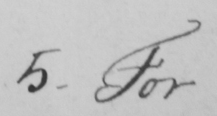What is written in this line of handwriting? 5 . For 